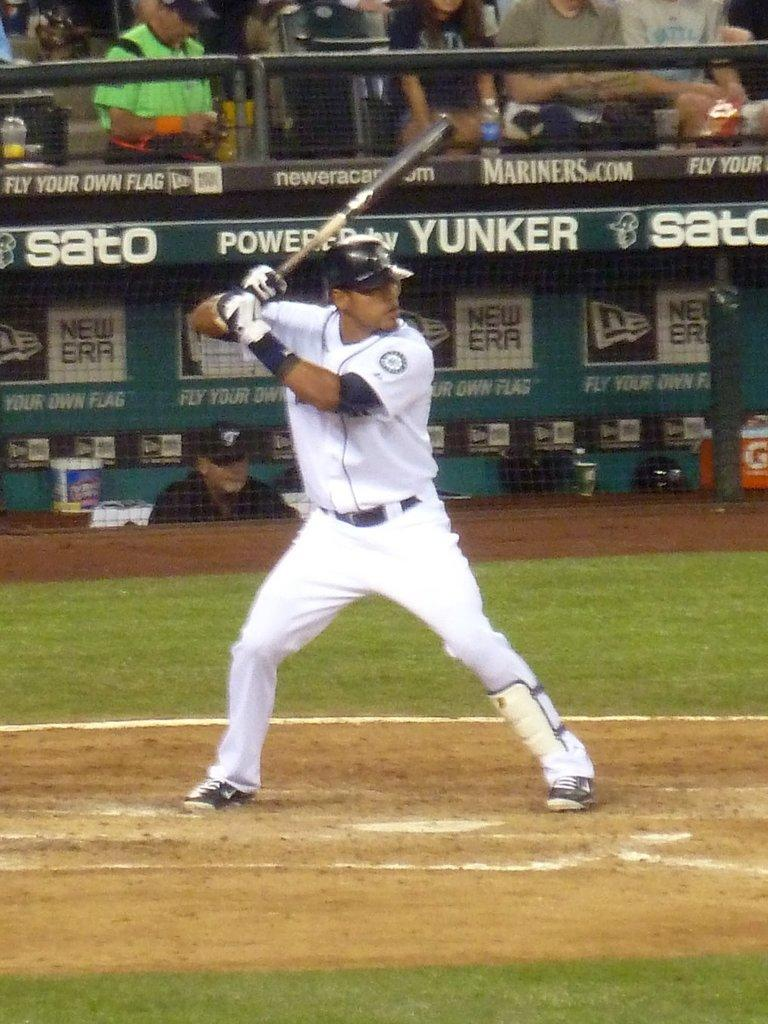Provide a one-sentence caption for the provided image. a dugout roof with the word yunker on the top edge. 